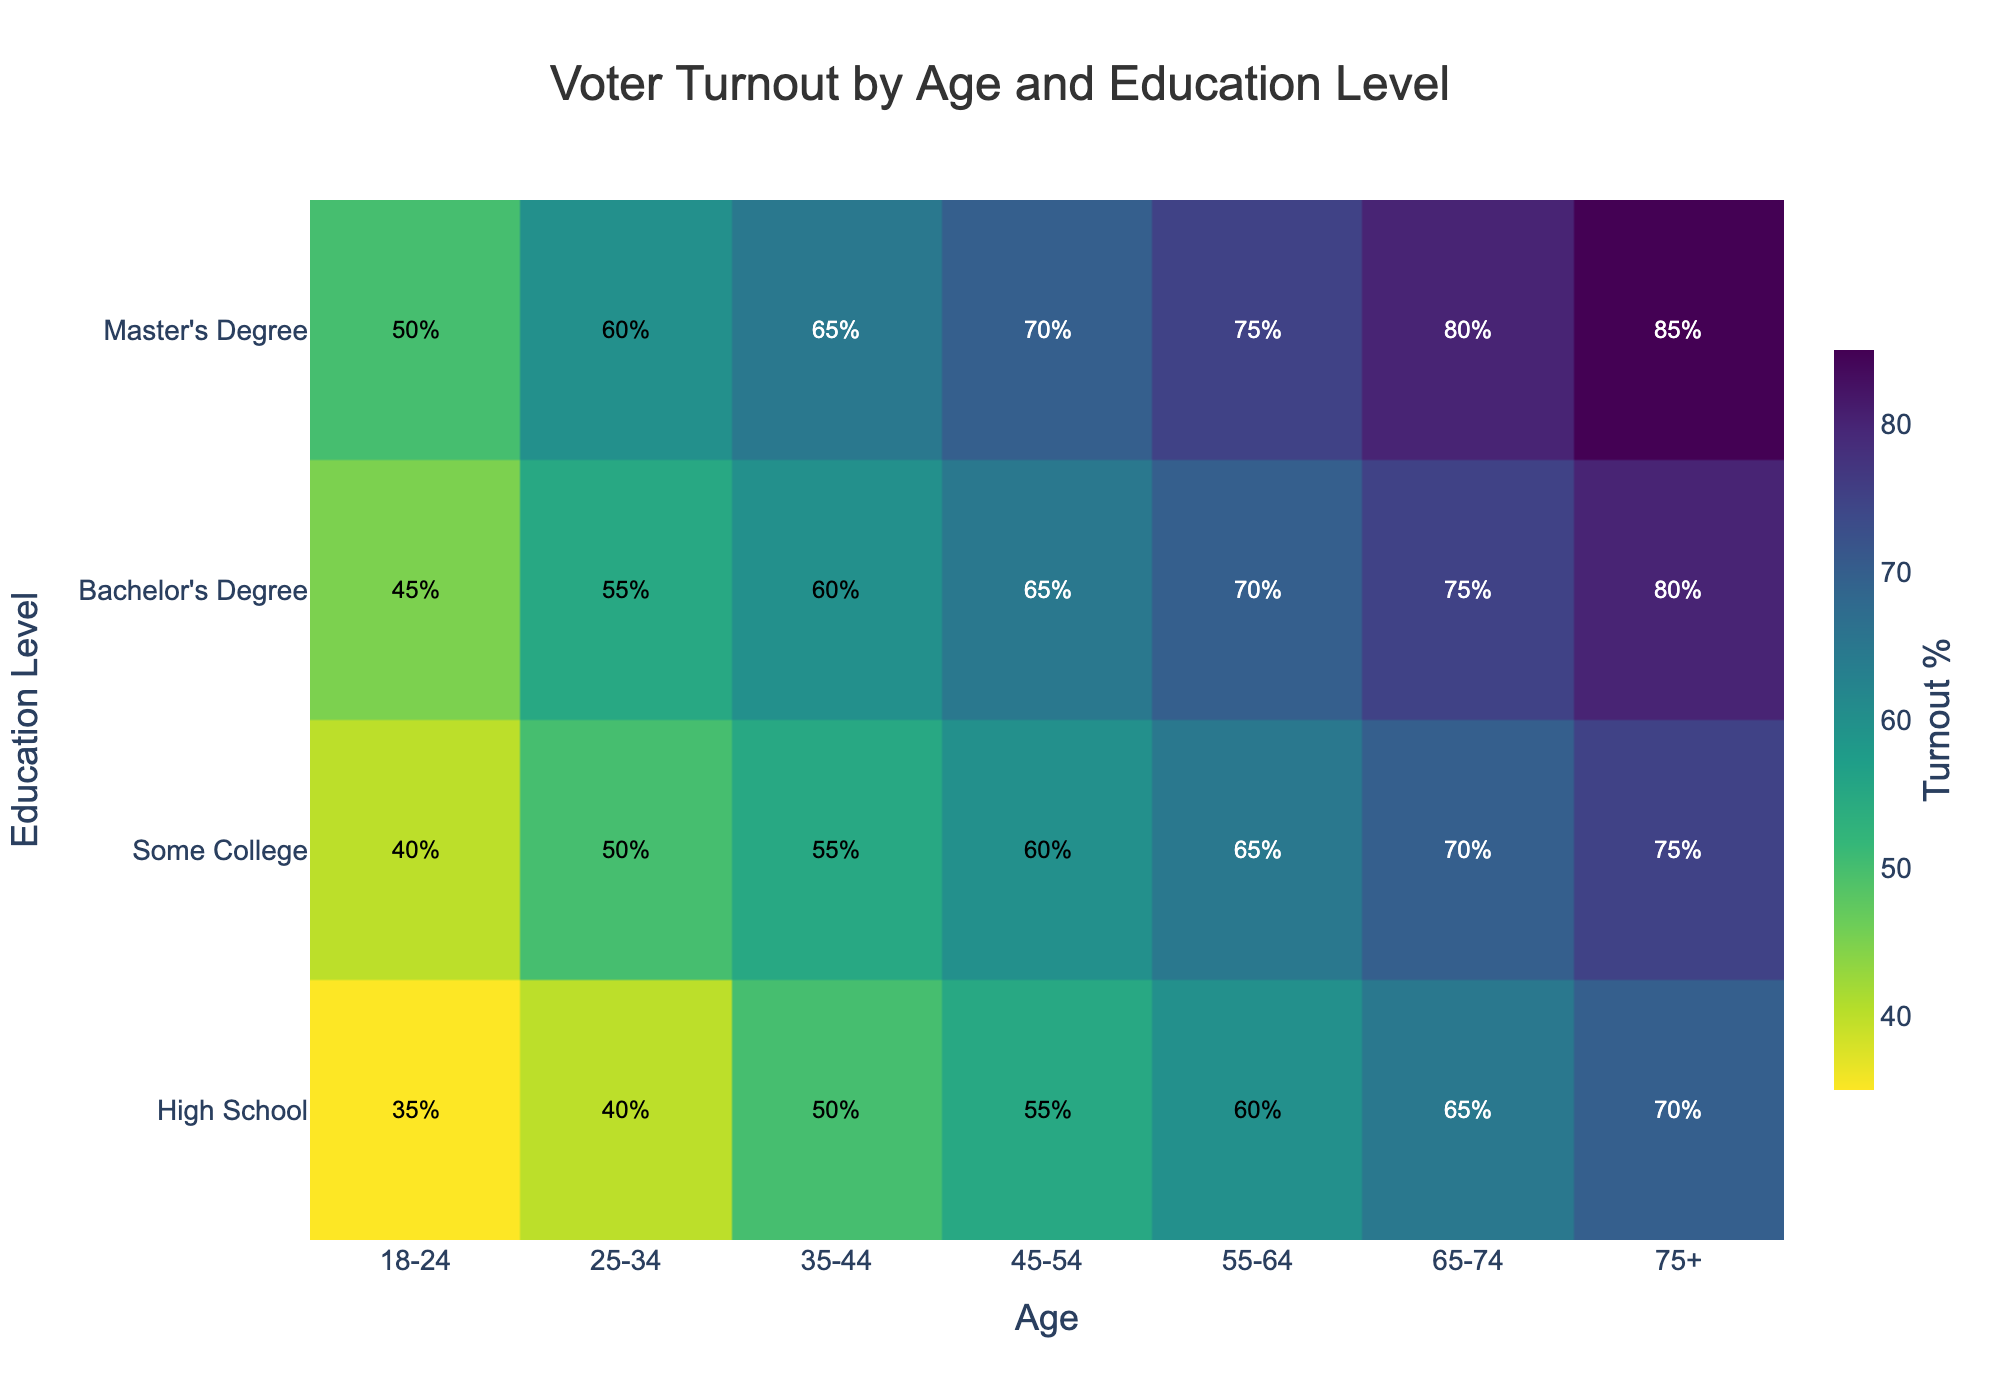What is the title of the density plot? The title of a plot is usually displayed prominently at the top of the figure. In this case, the title reads "Voter Turnout by Age and Education Level".
Answer: Voter Turnout by Age and Education Level What axis represents the age groups? The axis that lists different age groups like "18-24", "25-34", and so on is the x-axis. This is a typical format for age group representation.
Answer: x-axis Which education level has the highest voter turnout in the 75+ age group? To find this, look for the highest value in the y-axis for the 75+ age group marked on the x-axis. The highest voter turnout in this case is 85%, which corresponds to the "Master's Degree" education level.
Answer: Master's Degree What is the voter turnout percentage for individuals with a High School education level aged 35-44? Locate "35-44" on the x-axis and find the corresponding value for "High School" on the y-axis. The voter turnout listed is 50%.
Answer: 50% How does voter turnout for people with Some College education change from age group 25-34 to 45-54? Compare voter turnout values between "25-34" and "45-54" age groups for "Some College" education level. The turnout increases from 50% to 60%.
Answer: Increases from 50% to 60% Which age group has the lowest voter turnout and what is the corresponding education level? By scanning the plot, the lowest voter turnout is 35%, which occurs in the 18-24 age group with "High School" education level.
Answer: 18-24, High School Is there a general trend in voter turnout as education level increases within each age group? By observing the density plot, we see that for each age group, voter turnout increases as the education level goes up from High School to Master's Degree.
Answer: Increases What changes occur in the voter turnout for the 55-64 age group as education level improves? For the 55-64 age group, compare the values on the y-axis from High School (60%) to Master's Degree (75%). Voter turnout increases by 15 percentage points as education level improves.
Answer: Increases by 15 percentage points What's the difference in voter turnout between Bachelor’s Degree and Master’s Degree holders in the 35-44 age group? Compare the voter turnout percentages (60% for Bachelor’s, 65% for Master’s). The difference is 5 percentage points.
Answer: 5 percentage points Does voter turnout ever decrease with increasing education level within any age group? By scanning through the plot, we see that the voter turnout either remains constant or increases with education level across all age groups. No decreases are observed.
Answer: No 